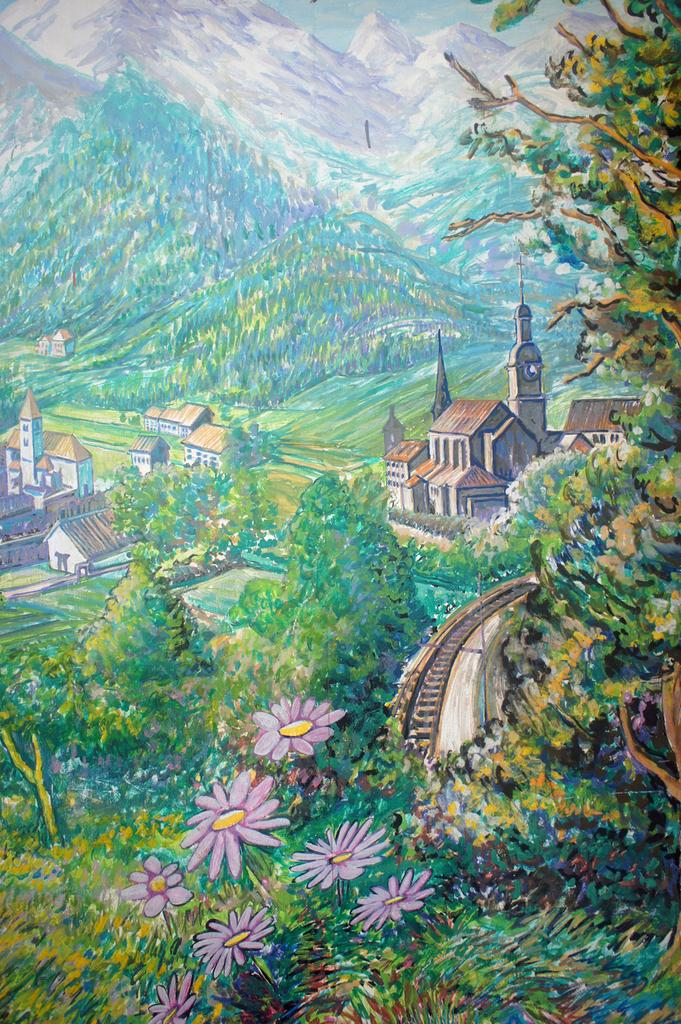What types of natural elements are present in the painting? The painting contains trees, flowers, and plants. What types of man-made structures are present in the painting? The painting contains buildings. What geographical feature is present in the painting? The painting contains mountains. What mode of transportation can be seen in the painting? There is a railway track in the painting. What part of the natural environment is visible in the background of the painting? The sky is visible in the background of the painting. Can you describe the worm crawling on the railway track in the painting? There is no worm present in the painting; it features trees, flowers, plants, buildings, mountains, a railway track, and a visible sky in the background. 